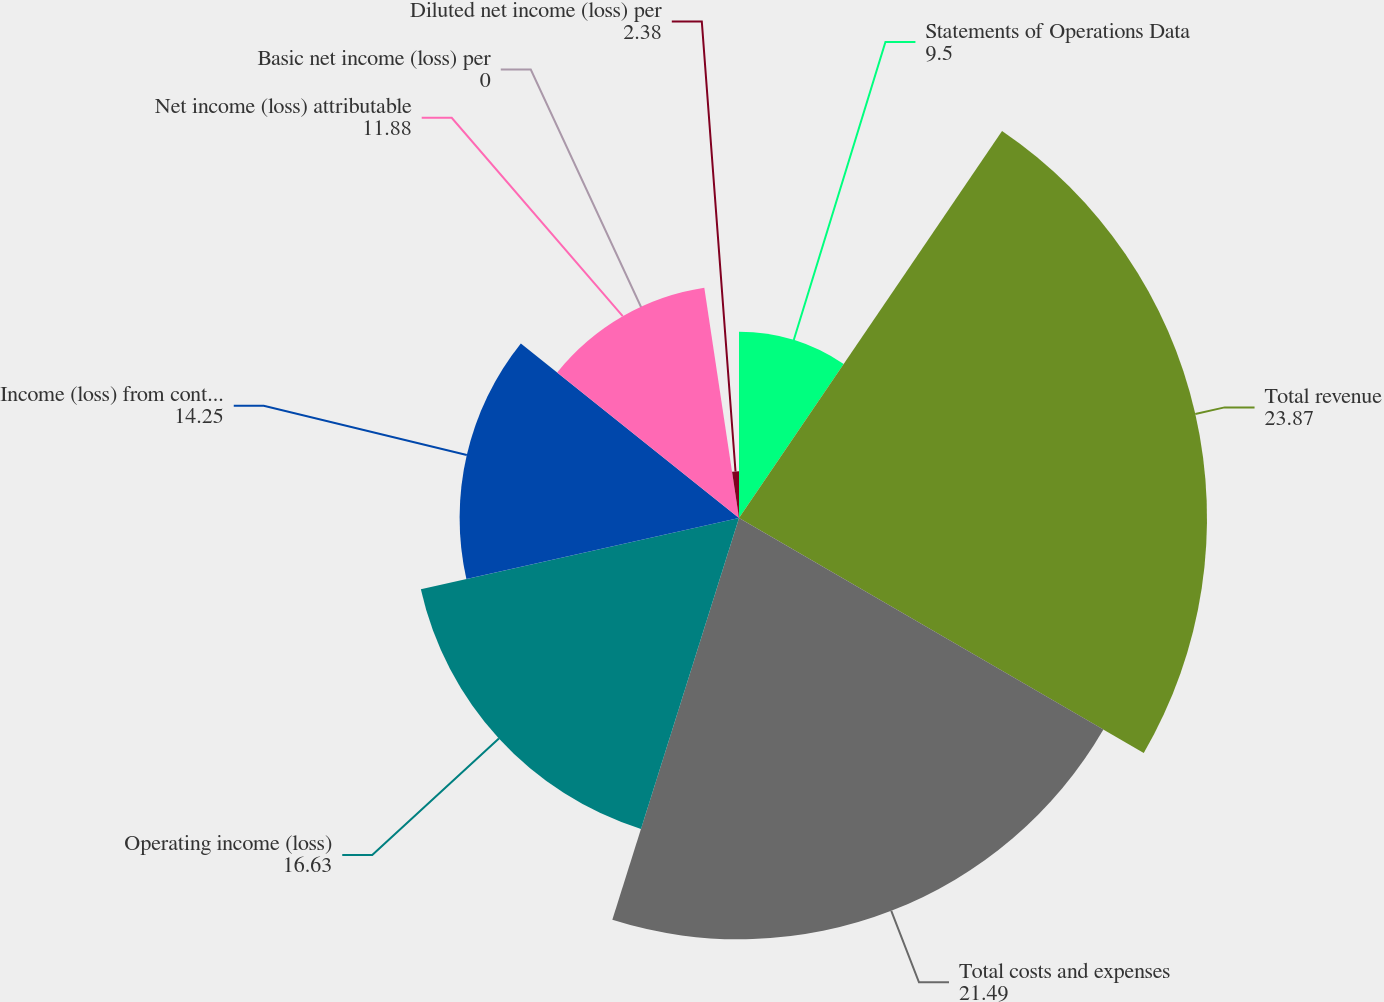Convert chart to OTSL. <chart><loc_0><loc_0><loc_500><loc_500><pie_chart><fcel>Statements of Operations Data<fcel>Total revenue<fcel>Total costs and expenses<fcel>Operating income (loss)<fcel>Income (loss) from continuing<fcel>Net income (loss) attributable<fcel>Basic net income (loss) per<fcel>Diluted net income (loss) per<nl><fcel>9.5%<fcel>23.87%<fcel>21.49%<fcel>16.63%<fcel>14.25%<fcel>11.88%<fcel>0.0%<fcel>2.38%<nl></chart> 